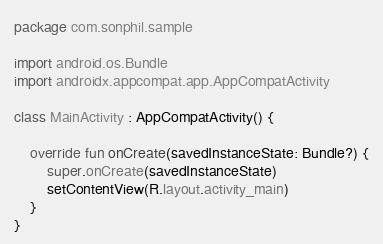<code> <loc_0><loc_0><loc_500><loc_500><_Kotlin_>package com.sonphil.sample

import android.os.Bundle
import androidx.appcompat.app.AppCompatActivity

class MainActivity : AppCompatActivity() {

    override fun onCreate(savedInstanceState: Bundle?) {
        super.onCreate(savedInstanceState)
        setContentView(R.layout.activity_main)
    }
}
</code> 